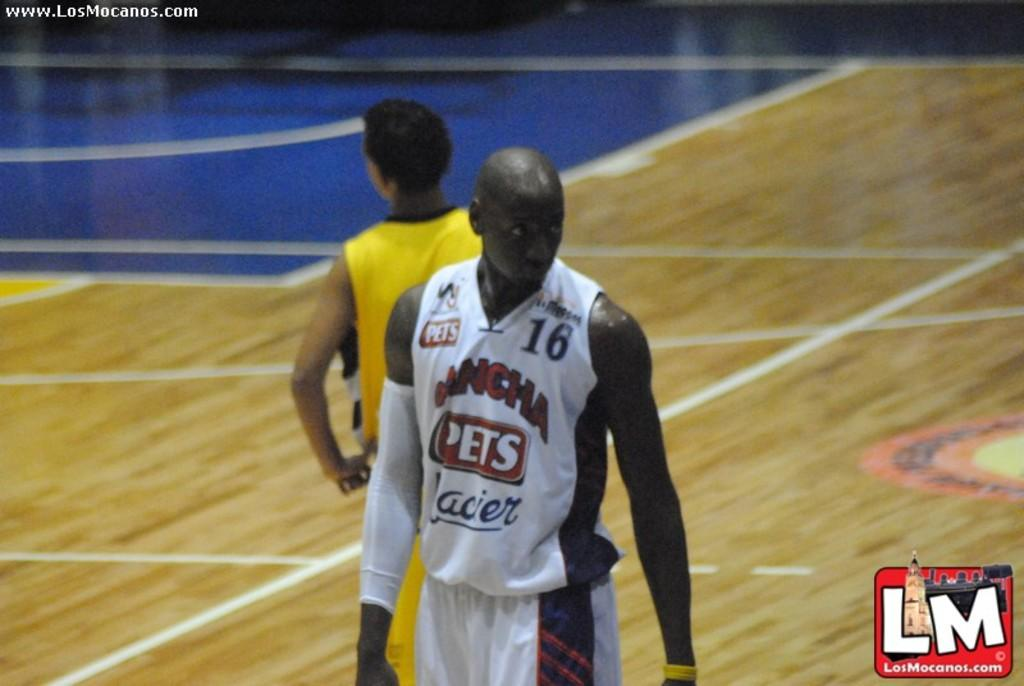How many people are present in the image? There are two persons standing in the image. What can be seen in the top left corner of the image? There are watermarks in the top left corner of the image. What can be seen in the bottom right corner of the image? There are watermarks in the bottom right corner of the image. What type of key is being used by one of the persons in the image? There is no key visible in the image; only the two persons standing are present. 